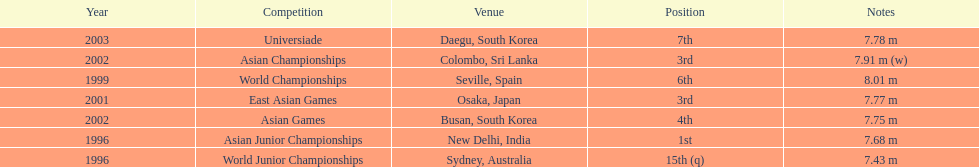Tell me the only venue in spain. Seville, Spain. 